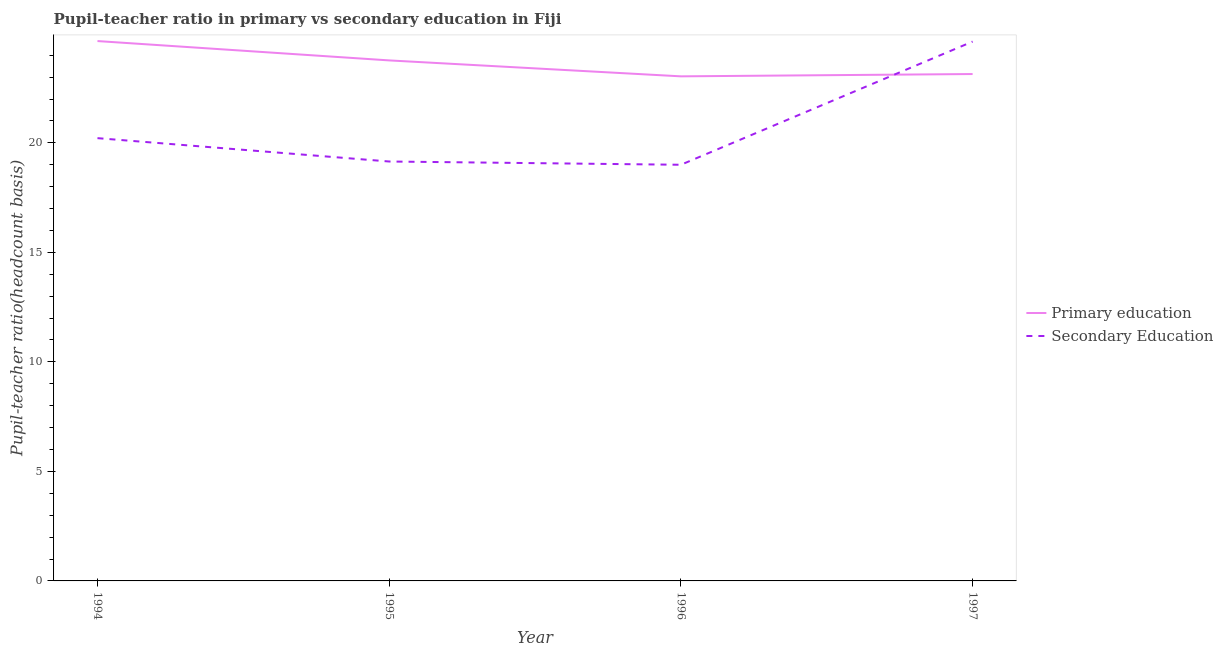How many different coloured lines are there?
Provide a succinct answer. 2. Does the line corresponding to pupil teacher ratio on secondary education intersect with the line corresponding to pupil-teacher ratio in primary education?
Ensure brevity in your answer.  Yes. What is the pupil teacher ratio on secondary education in 1996?
Your response must be concise. 19. Across all years, what is the maximum pupil teacher ratio on secondary education?
Your answer should be compact. 24.62. Across all years, what is the minimum pupil teacher ratio on secondary education?
Your answer should be very brief. 19. In which year was the pupil teacher ratio on secondary education minimum?
Offer a very short reply. 1996. What is the total pupil teacher ratio on secondary education in the graph?
Provide a succinct answer. 82.99. What is the difference between the pupil teacher ratio on secondary education in 1995 and that in 1997?
Your answer should be compact. -5.48. What is the difference between the pupil-teacher ratio in primary education in 1996 and the pupil teacher ratio on secondary education in 1997?
Your response must be concise. -1.59. What is the average pupil-teacher ratio in primary education per year?
Your answer should be compact. 23.65. In the year 1994, what is the difference between the pupil-teacher ratio in primary education and pupil teacher ratio on secondary education?
Ensure brevity in your answer.  4.43. In how many years, is the pupil-teacher ratio in primary education greater than 4?
Make the answer very short. 4. What is the ratio of the pupil teacher ratio on secondary education in 1995 to that in 1996?
Ensure brevity in your answer.  1.01. Is the pupil-teacher ratio in primary education in 1995 less than that in 1996?
Give a very brief answer. No. Is the difference between the pupil teacher ratio on secondary education in 1996 and 1997 greater than the difference between the pupil-teacher ratio in primary education in 1996 and 1997?
Your answer should be compact. No. What is the difference between the highest and the second highest pupil-teacher ratio in primary education?
Provide a short and direct response. 0.88. What is the difference between the highest and the lowest pupil-teacher ratio in primary education?
Make the answer very short. 1.61. Is the sum of the pupil teacher ratio on secondary education in 1994 and 1997 greater than the maximum pupil-teacher ratio in primary education across all years?
Offer a terse response. Yes. Does the pupil-teacher ratio in primary education monotonically increase over the years?
Provide a succinct answer. No. Is the pupil teacher ratio on secondary education strictly greater than the pupil-teacher ratio in primary education over the years?
Offer a very short reply. No. Is the pupil teacher ratio on secondary education strictly less than the pupil-teacher ratio in primary education over the years?
Offer a very short reply. No. How many lines are there?
Your answer should be compact. 2. How many years are there in the graph?
Offer a very short reply. 4. What is the difference between two consecutive major ticks on the Y-axis?
Offer a terse response. 5. Does the graph contain any zero values?
Offer a very short reply. No. How are the legend labels stacked?
Offer a terse response. Vertical. What is the title of the graph?
Give a very brief answer. Pupil-teacher ratio in primary vs secondary education in Fiji. Does "Diarrhea" appear as one of the legend labels in the graph?
Provide a succinct answer. No. What is the label or title of the Y-axis?
Make the answer very short. Pupil-teacher ratio(headcount basis). What is the Pupil-teacher ratio(headcount basis) of Primary education in 1994?
Your answer should be very brief. 24.65. What is the Pupil-teacher ratio(headcount basis) of Secondary Education in 1994?
Give a very brief answer. 20.21. What is the Pupil-teacher ratio(headcount basis) of Primary education in 1995?
Provide a succinct answer. 23.76. What is the Pupil-teacher ratio(headcount basis) of Secondary Education in 1995?
Keep it short and to the point. 19.15. What is the Pupil-teacher ratio(headcount basis) in Primary education in 1996?
Offer a terse response. 23.04. What is the Pupil-teacher ratio(headcount basis) in Secondary Education in 1996?
Provide a short and direct response. 19. What is the Pupil-teacher ratio(headcount basis) in Primary education in 1997?
Offer a very short reply. 23.14. What is the Pupil-teacher ratio(headcount basis) in Secondary Education in 1997?
Give a very brief answer. 24.62. Across all years, what is the maximum Pupil-teacher ratio(headcount basis) of Primary education?
Provide a short and direct response. 24.65. Across all years, what is the maximum Pupil-teacher ratio(headcount basis) of Secondary Education?
Offer a terse response. 24.62. Across all years, what is the minimum Pupil-teacher ratio(headcount basis) in Primary education?
Keep it short and to the point. 23.04. Across all years, what is the minimum Pupil-teacher ratio(headcount basis) in Secondary Education?
Make the answer very short. 19. What is the total Pupil-teacher ratio(headcount basis) in Primary education in the graph?
Your answer should be very brief. 94.59. What is the total Pupil-teacher ratio(headcount basis) of Secondary Education in the graph?
Provide a succinct answer. 82.99. What is the difference between the Pupil-teacher ratio(headcount basis) in Primary education in 1994 and that in 1995?
Provide a short and direct response. 0.88. What is the difference between the Pupil-teacher ratio(headcount basis) in Secondary Education in 1994 and that in 1995?
Provide a succinct answer. 1.07. What is the difference between the Pupil-teacher ratio(headcount basis) in Primary education in 1994 and that in 1996?
Your answer should be very brief. 1.61. What is the difference between the Pupil-teacher ratio(headcount basis) of Secondary Education in 1994 and that in 1996?
Offer a very short reply. 1.22. What is the difference between the Pupil-teacher ratio(headcount basis) of Primary education in 1994 and that in 1997?
Provide a succinct answer. 1.51. What is the difference between the Pupil-teacher ratio(headcount basis) of Secondary Education in 1994 and that in 1997?
Give a very brief answer. -4.41. What is the difference between the Pupil-teacher ratio(headcount basis) of Primary education in 1995 and that in 1996?
Ensure brevity in your answer.  0.73. What is the difference between the Pupil-teacher ratio(headcount basis) of Secondary Education in 1995 and that in 1996?
Offer a very short reply. 0.15. What is the difference between the Pupil-teacher ratio(headcount basis) of Primary education in 1995 and that in 1997?
Offer a very short reply. 0.62. What is the difference between the Pupil-teacher ratio(headcount basis) of Secondary Education in 1995 and that in 1997?
Make the answer very short. -5.48. What is the difference between the Pupil-teacher ratio(headcount basis) in Primary education in 1996 and that in 1997?
Your answer should be very brief. -0.11. What is the difference between the Pupil-teacher ratio(headcount basis) of Secondary Education in 1996 and that in 1997?
Provide a short and direct response. -5.62. What is the difference between the Pupil-teacher ratio(headcount basis) of Primary education in 1994 and the Pupil-teacher ratio(headcount basis) of Secondary Education in 1995?
Offer a very short reply. 5.5. What is the difference between the Pupil-teacher ratio(headcount basis) in Primary education in 1994 and the Pupil-teacher ratio(headcount basis) in Secondary Education in 1996?
Your answer should be compact. 5.65. What is the difference between the Pupil-teacher ratio(headcount basis) of Primary education in 1994 and the Pupil-teacher ratio(headcount basis) of Secondary Education in 1997?
Provide a short and direct response. 0.02. What is the difference between the Pupil-teacher ratio(headcount basis) of Primary education in 1995 and the Pupil-teacher ratio(headcount basis) of Secondary Education in 1996?
Provide a short and direct response. 4.76. What is the difference between the Pupil-teacher ratio(headcount basis) of Primary education in 1995 and the Pupil-teacher ratio(headcount basis) of Secondary Education in 1997?
Offer a very short reply. -0.86. What is the difference between the Pupil-teacher ratio(headcount basis) in Primary education in 1996 and the Pupil-teacher ratio(headcount basis) in Secondary Education in 1997?
Your answer should be very brief. -1.59. What is the average Pupil-teacher ratio(headcount basis) of Primary education per year?
Your response must be concise. 23.65. What is the average Pupil-teacher ratio(headcount basis) of Secondary Education per year?
Your answer should be compact. 20.75. In the year 1994, what is the difference between the Pupil-teacher ratio(headcount basis) of Primary education and Pupil-teacher ratio(headcount basis) of Secondary Education?
Give a very brief answer. 4.43. In the year 1995, what is the difference between the Pupil-teacher ratio(headcount basis) of Primary education and Pupil-teacher ratio(headcount basis) of Secondary Education?
Provide a short and direct response. 4.62. In the year 1996, what is the difference between the Pupil-teacher ratio(headcount basis) in Primary education and Pupil-teacher ratio(headcount basis) in Secondary Education?
Your answer should be very brief. 4.04. In the year 1997, what is the difference between the Pupil-teacher ratio(headcount basis) in Primary education and Pupil-teacher ratio(headcount basis) in Secondary Education?
Keep it short and to the point. -1.48. What is the ratio of the Pupil-teacher ratio(headcount basis) in Primary education in 1994 to that in 1995?
Provide a short and direct response. 1.04. What is the ratio of the Pupil-teacher ratio(headcount basis) in Secondary Education in 1994 to that in 1995?
Offer a terse response. 1.06. What is the ratio of the Pupil-teacher ratio(headcount basis) of Primary education in 1994 to that in 1996?
Give a very brief answer. 1.07. What is the ratio of the Pupil-teacher ratio(headcount basis) in Secondary Education in 1994 to that in 1996?
Provide a succinct answer. 1.06. What is the ratio of the Pupil-teacher ratio(headcount basis) in Primary education in 1994 to that in 1997?
Provide a short and direct response. 1.06. What is the ratio of the Pupil-teacher ratio(headcount basis) in Secondary Education in 1994 to that in 1997?
Offer a terse response. 0.82. What is the ratio of the Pupil-teacher ratio(headcount basis) of Primary education in 1995 to that in 1996?
Your answer should be compact. 1.03. What is the ratio of the Pupil-teacher ratio(headcount basis) in Primary education in 1995 to that in 1997?
Provide a succinct answer. 1.03. What is the ratio of the Pupil-teacher ratio(headcount basis) in Secondary Education in 1995 to that in 1997?
Keep it short and to the point. 0.78. What is the ratio of the Pupil-teacher ratio(headcount basis) of Secondary Education in 1996 to that in 1997?
Keep it short and to the point. 0.77. What is the difference between the highest and the second highest Pupil-teacher ratio(headcount basis) in Primary education?
Keep it short and to the point. 0.88. What is the difference between the highest and the second highest Pupil-teacher ratio(headcount basis) in Secondary Education?
Ensure brevity in your answer.  4.41. What is the difference between the highest and the lowest Pupil-teacher ratio(headcount basis) of Primary education?
Ensure brevity in your answer.  1.61. What is the difference between the highest and the lowest Pupil-teacher ratio(headcount basis) of Secondary Education?
Keep it short and to the point. 5.62. 